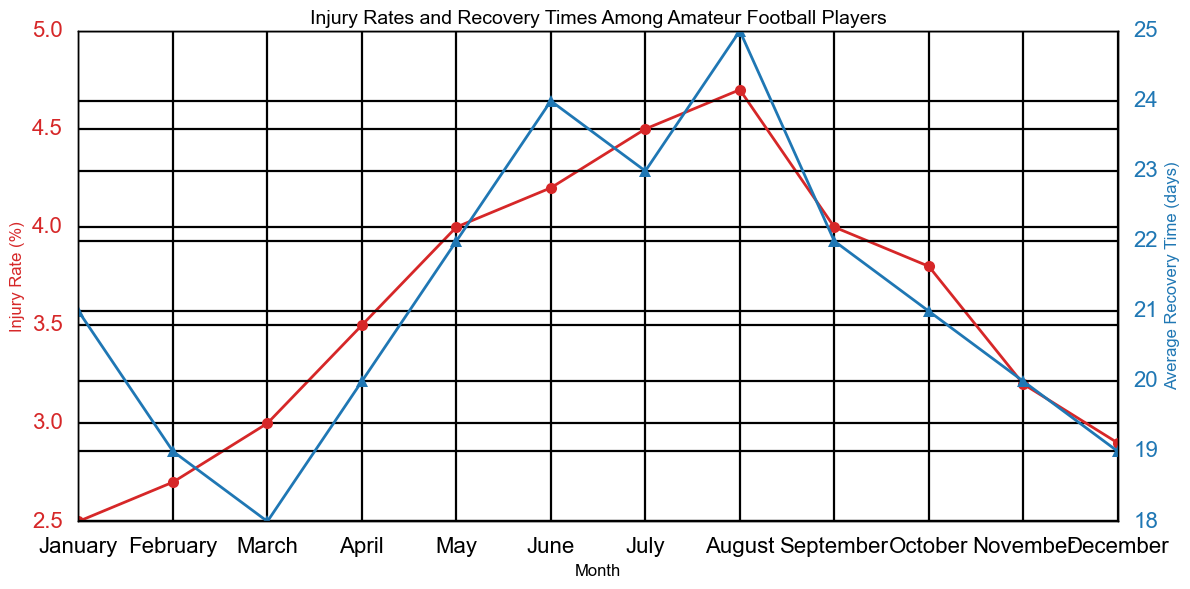Which month has the highest injury rate? Look at the "Injury Rate (%)" line, which is red, and find the peak point. The highest injury rate occurs in August at 4.7%.
Answer: August When does the average recovery time peak during the year? Examine the "Average Recovery Time (days)" line, which is blue, and identify the highest point. The peak average recovery time occurs in August at 25 days.
Answer: August How does the injury rate in January compare to December? Look at the "Injury Rate (%)" data points for January and December. Injury rates in January and December are 2.5% and 2.9%, respectively, so December is higher.
Answer: December is higher What is the difference in average recovery time between May and September? Check the blue line for May and September to find their values, which are 22 days and 22 days, respectively. Their difference is 0 days.
Answer: 0 days What is the combined injury rate for June and July? Find the injury rates for June and July on the red line (4.2% and 4.5%, respectively). Summing them up gives 4.2 + 4.5 = 8.7%.
Answer: 8.7% Which month has the lowest average recovery time? Find the lowest point on the blue line representing "Average Recovery Time (days)". The lowest value is 18 days in March.
Answer: March How many months have an injury rate greater than 4%? Count the red data points on the graph that are above the 4% mark, corresponding to May, June, July, and August, which equals four months.
Answer: 4 months Is the trend of injury rates from January to August increasing or decreasing? Observe the slope of the red line from January to August. The trend shows a continuous increase.
Answer: Increasing What is the average injury rate over the year? Find the sum of the injury rates for all months and divide by 12: (2.5 + 2.7 + 3.0 + 3.5 + 4.0 + 4.2 + 4.5 + 4.7 + 4.0 + 3.8 + 3.2 + 2.9) / 12 = 3.63%.
Answer: 3.63% Which month sees the most significant drop in recovery time compared to the previous month? Compare the blue line data points for each consecutive month and look for the biggest decrease. The greatest drop is from July to August (23 to 22 days down to 19 days in January).
Answer: January 